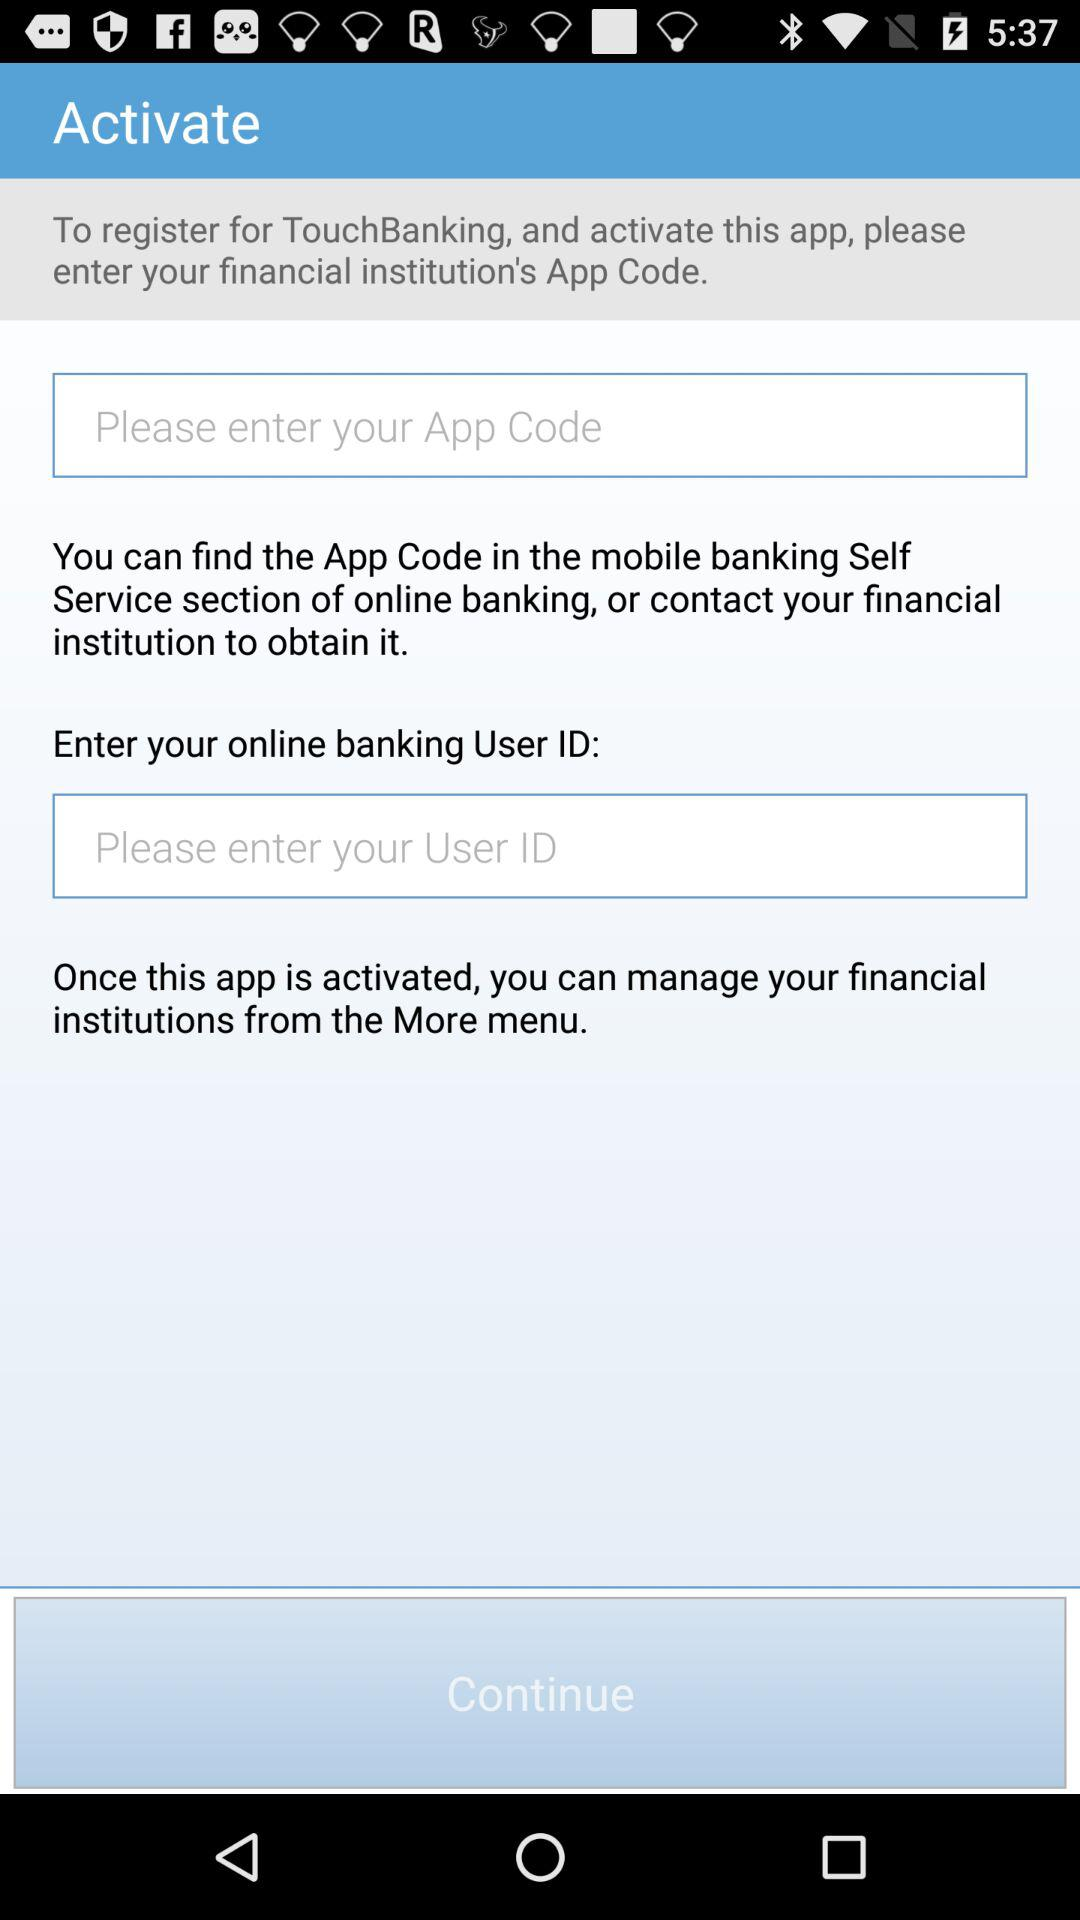How many input fields are required to activate the app?
Answer the question using a single word or phrase. 2 